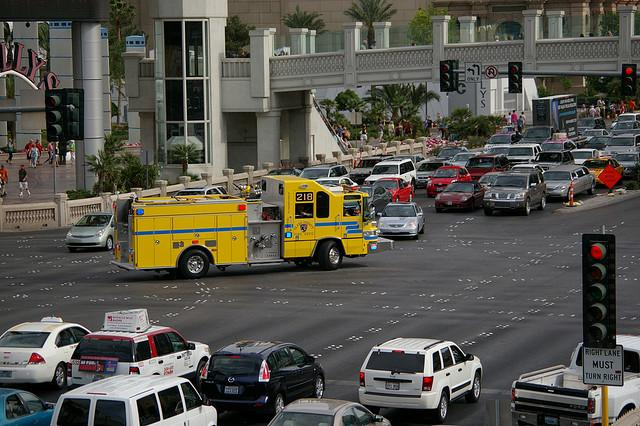Why are all the other cars letting the yellow truck go? emergency 